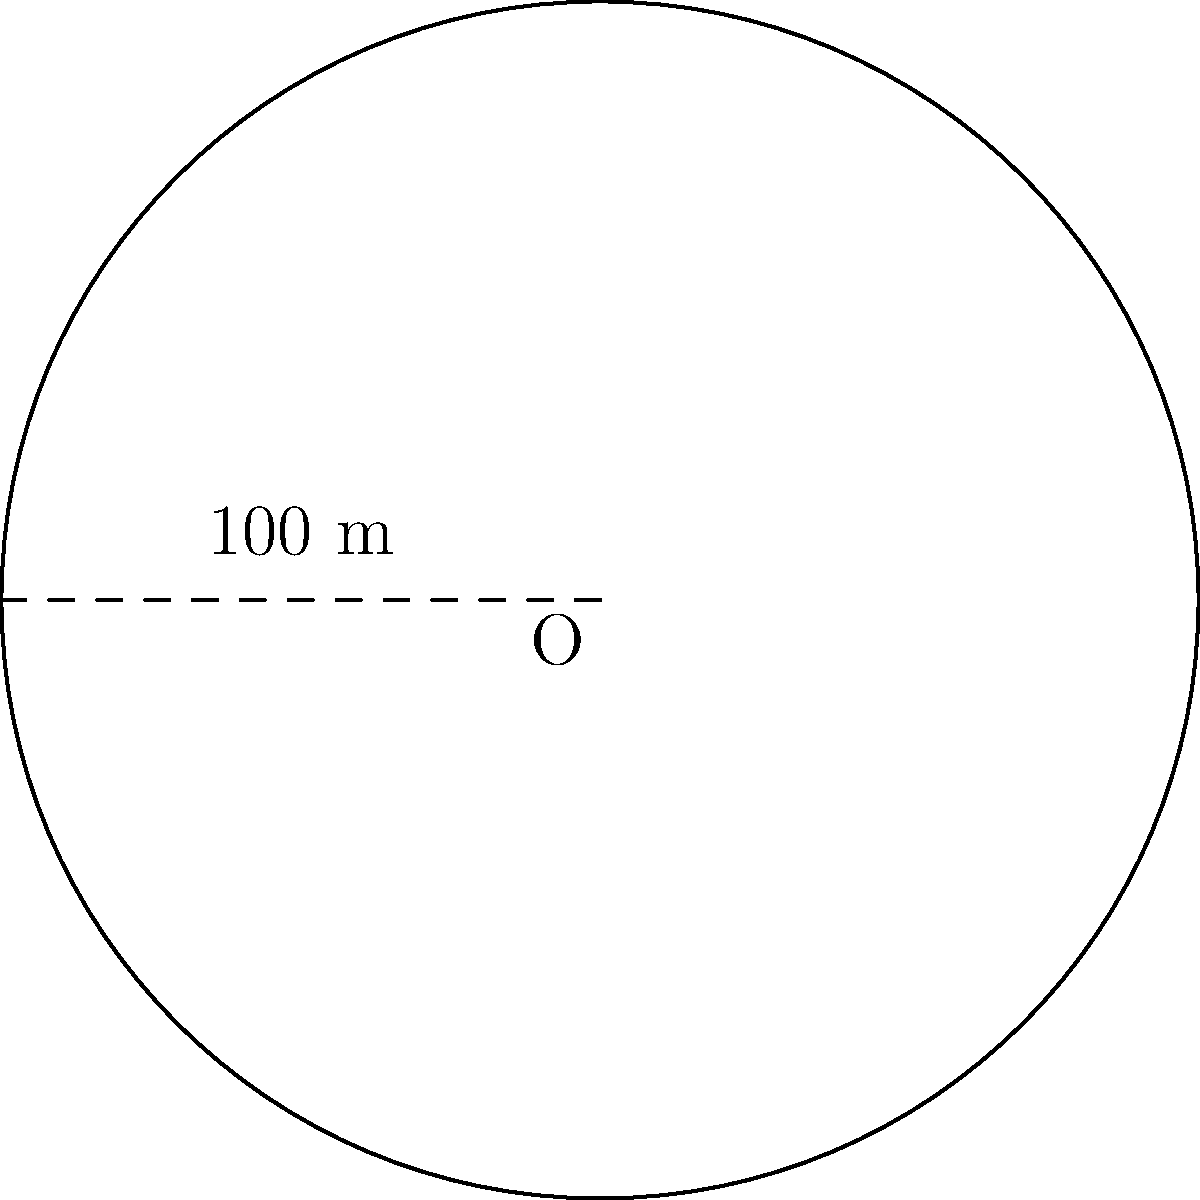A circular walking track is designed for cardiac patients' exercise routines. If the radius of the track is 50 meters, what is the perimeter of the track that patients will walk along? To find the perimeter of the circular walking track, we need to calculate its circumference. The formula for the circumference of a circle is:

$$C = 2\pi r$$

Where:
$C$ = circumference
$\pi$ = pi (approximately 3.14159)
$r$ = radius

Given:
- Radius of the track = 50 meters

Step 1: Substitute the values into the formula
$$C = 2\pi(50)$$

Step 2: Calculate
$$C = 100\pi \approx 314.16$$

Therefore, the perimeter of the circular walking track is approximately 314.16 meters.
Answer: $314.16$ meters 